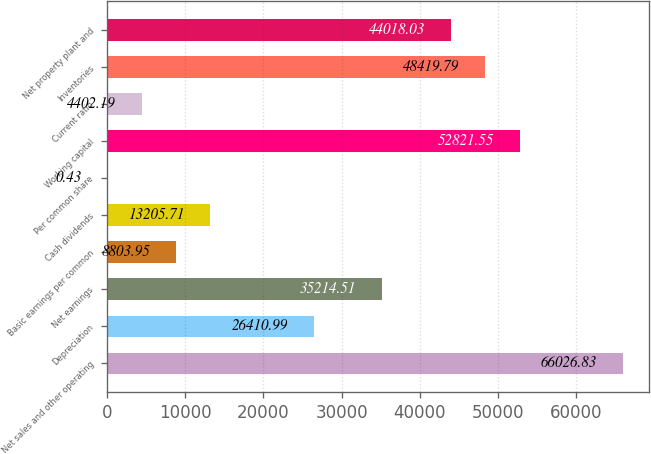Convert chart to OTSL. <chart><loc_0><loc_0><loc_500><loc_500><bar_chart><fcel>Net sales and other operating<fcel>Depreciation<fcel>Net earnings<fcel>Basic earnings per common<fcel>Cash dividends<fcel>Per common share<fcel>Working capital<fcel>Current ratio<fcel>Inventories<fcel>Net property plant and<nl><fcel>66026.8<fcel>26411<fcel>35214.5<fcel>8803.95<fcel>13205.7<fcel>0.43<fcel>52821.6<fcel>4402.19<fcel>48419.8<fcel>44018<nl></chart> 